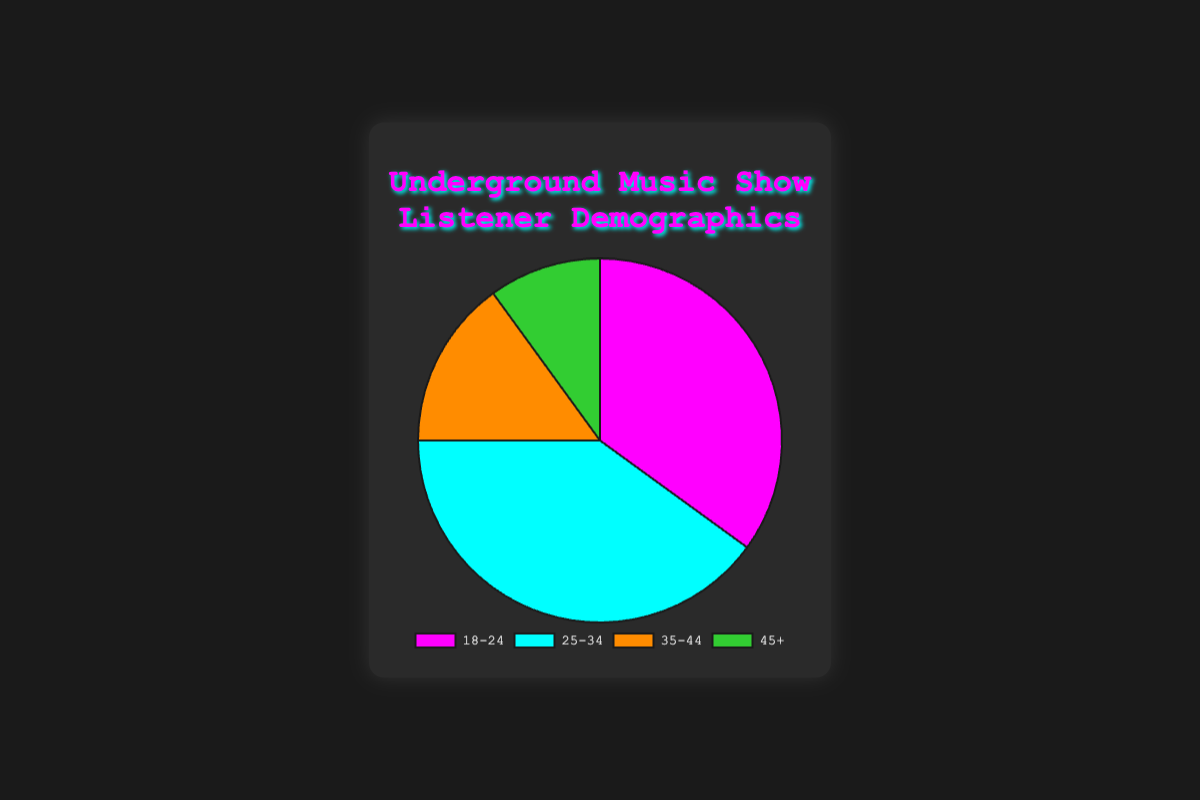What percentage of listeners are aged 25-34? By referring to the figure, the segment labeled "25-34" shows 40%.
Answer: 40% Which age group has the smallest listener percentage? By observing the figure, the "45+" segment is the smallest at 10%.
Answer: 45+ How much more popular is the 25-34 age group compared to the 35-44 age group? The 25-34 group has 40% and the 35-44 group has 15%. The difference is 40% - 15% = 25%.
Answer: 25% What is the combined percentage of listeners aged 18-34? Adding the percentages of the 18-24 and 25-34 groups: 35% + 40% = 75%.
Answer: 75% Which color represents the 35-44 age group in the chart? By referring to the visual attributes, the 35-44 segment is represented by an orange color.
Answer: Orange Is the percentage of listeners aged 25-34 more than double the percentage of those aged 45+? The percentage for 25-34 is 40%, and for 45+ it's 10%. Checking if 40% is more than double 10%: 2 * 10% = 20%, and 40% > 20%.
Answer: Yes Which two age groups together make up more than half of the listeners? Adding the two largest segments: 18-24 is 35% and 25-34 is 40%. 35% + 40% = 75%, which is more than half of the total listeners.
Answer: 18-24 and 25-34 What percentage of listeners are older than 34? Adding the percentages of the 35-44 and 45+ groups: 15% + 10% = 25%.
Answer: 25% What is the range of listener percentages across the age groups? The highest percentage is 40% (25-34) and the lowest is 10% (45+). The range is 40% - 10% = 30%.
Answer: 30% 